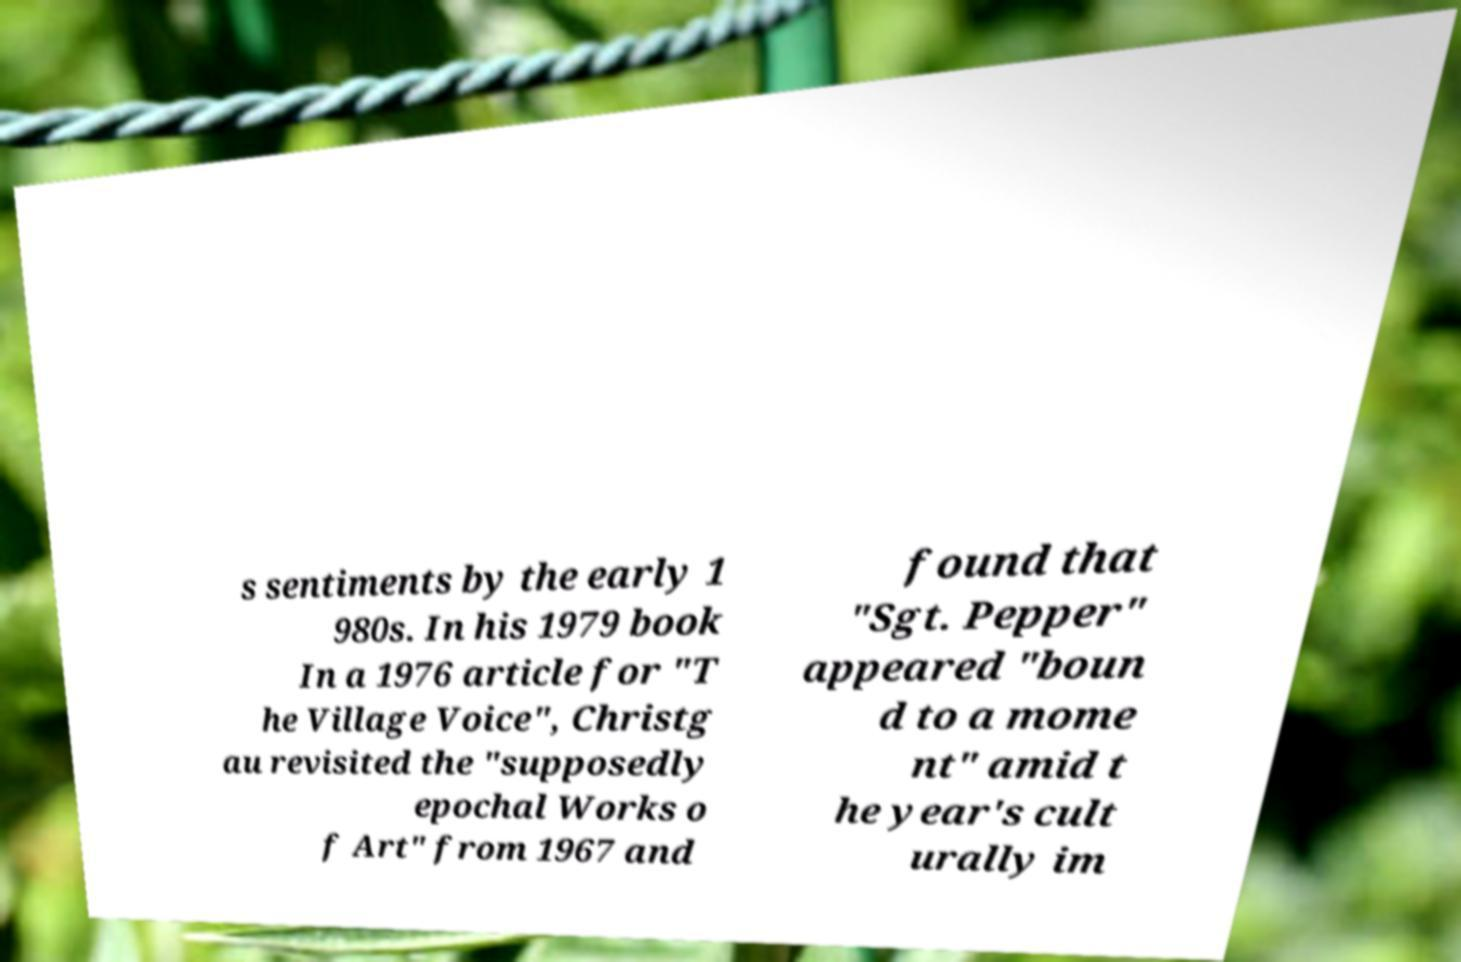Could you assist in decoding the text presented in this image and type it out clearly? s sentiments by the early 1 980s. In his 1979 book In a 1976 article for "T he Village Voice", Christg au revisited the "supposedly epochal Works o f Art" from 1967 and found that "Sgt. Pepper" appeared "boun d to a mome nt" amid t he year's cult urally im 